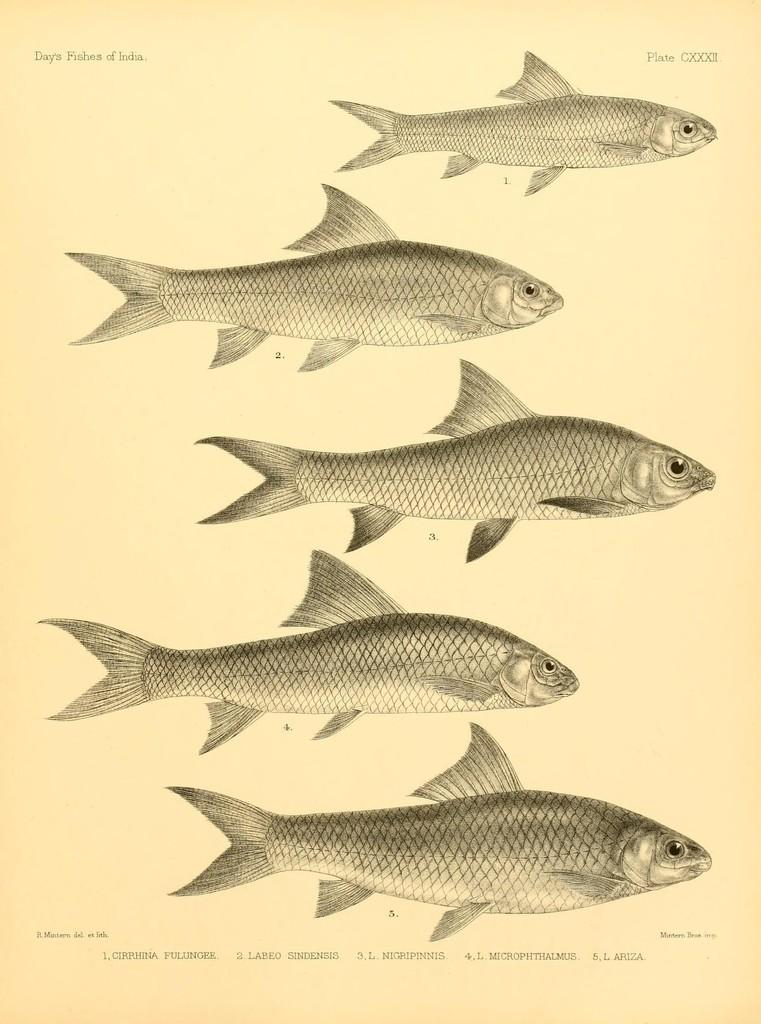What is the main subject of the image? The main subject of the image is a page of a book. What can be seen on the page of the book? The page contains images of five fishes. What type of apple is being eaten during the rain in the image? There is no apple or rain present in the image; it only features a page of a book with images of five fishes. 